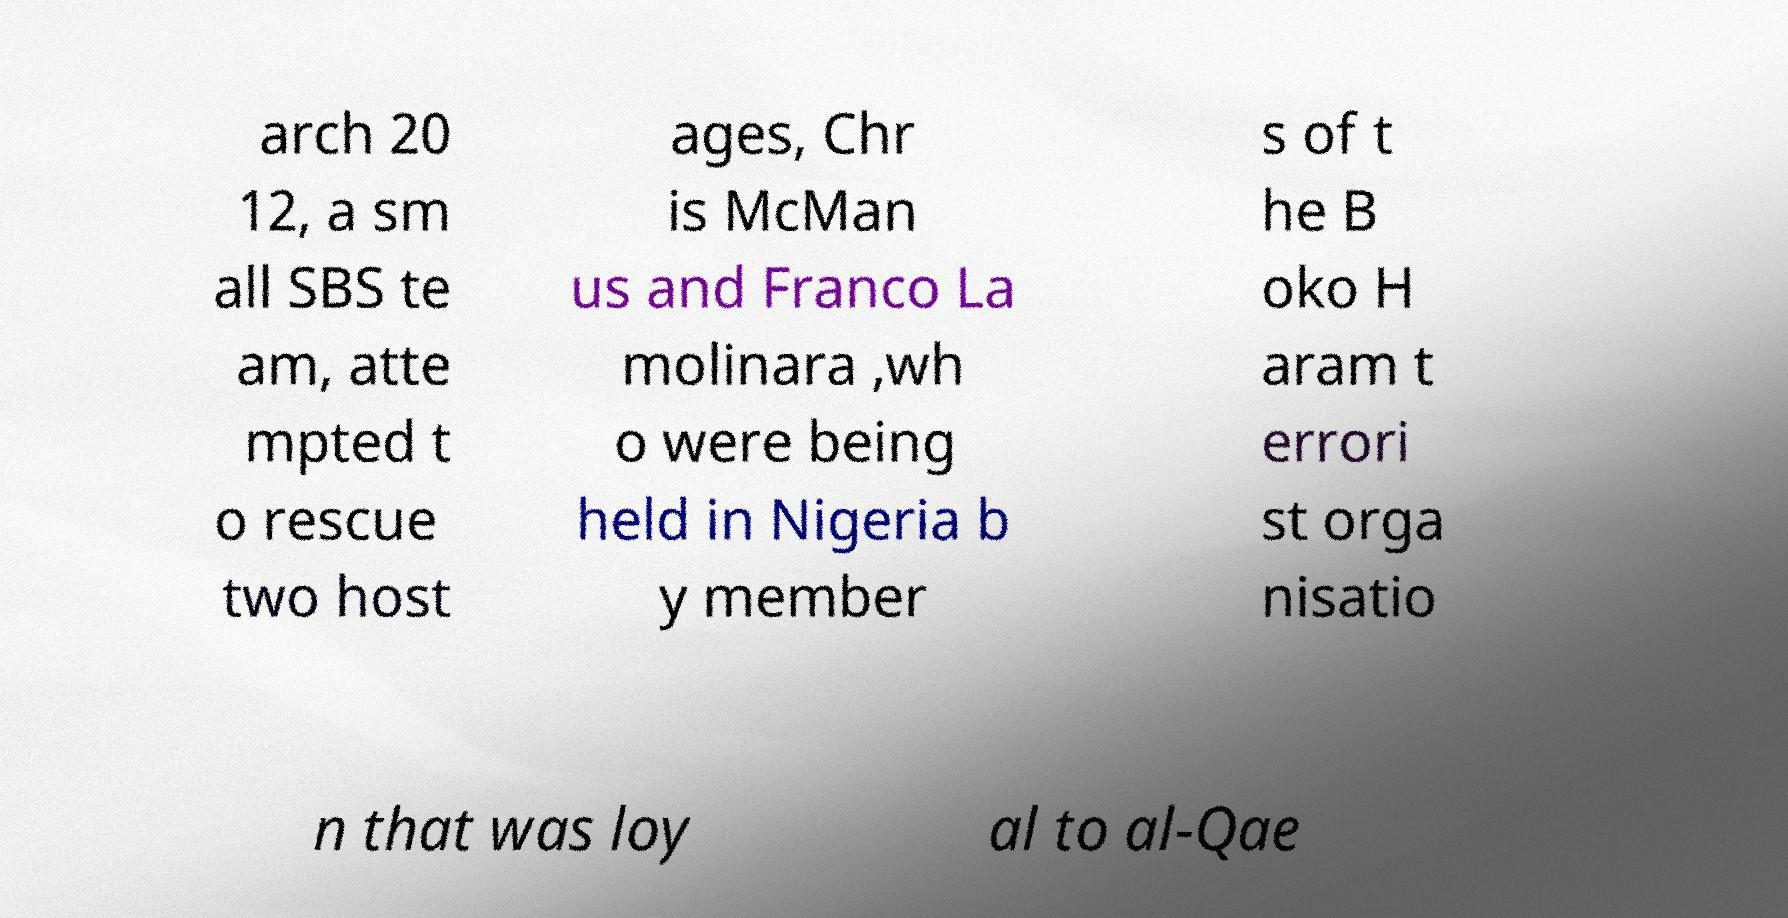There's text embedded in this image that I need extracted. Can you transcribe it verbatim? arch 20 12, a sm all SBS te am, atte mpted t o rescue two host ages, Chr is McMan us and Franco La molinara ,wh o were being held in Nigeria b y member s of t he B oko H aram t errori st orga nisatio n that was loy al to al-Qae 